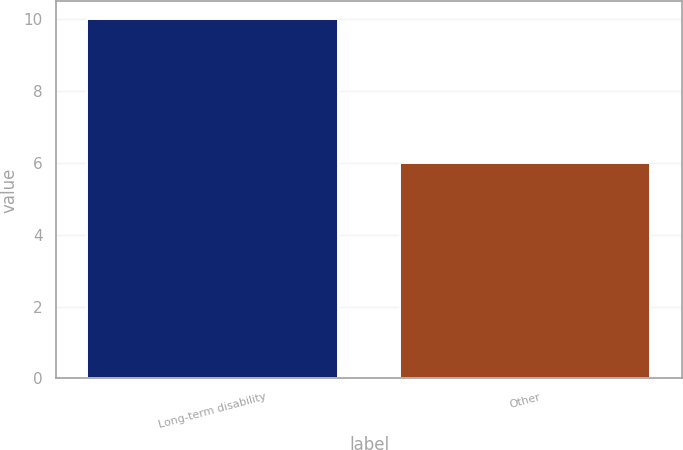Convert chart. <chart><loc_0><loc_0><loc_500><loc_500><bar_chart><fcel>Long-term disability<fcel>Other<nl><fcel>10<fcel>6<nl></chart> 